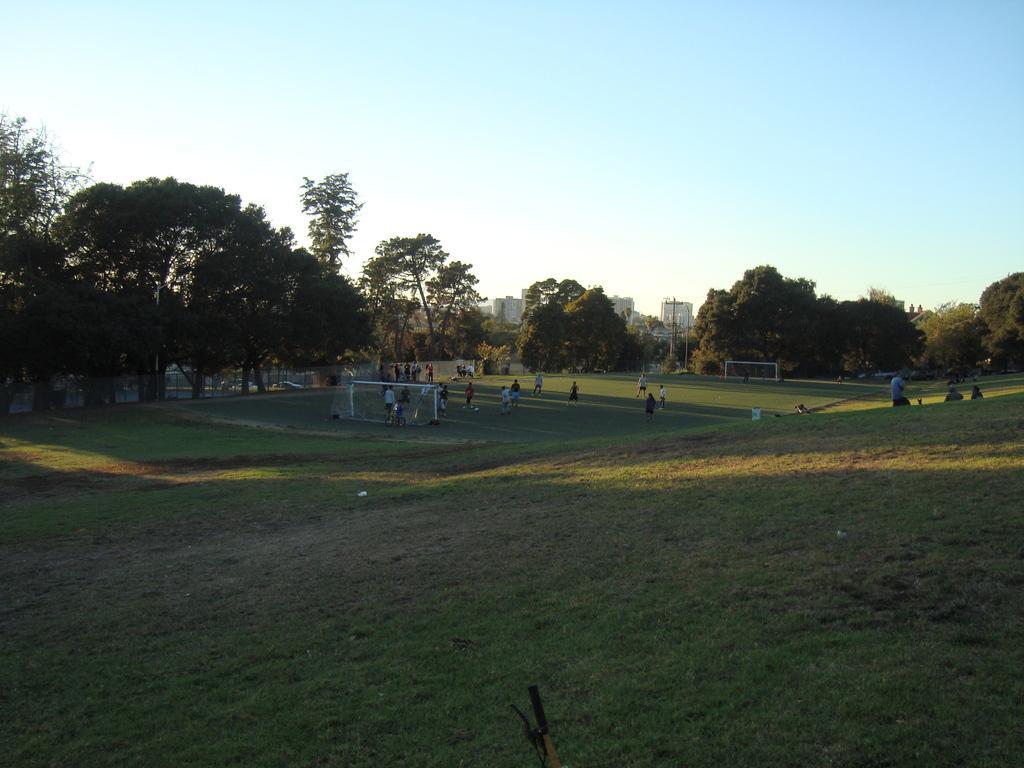Can you describe this image briefly? These are the trees with branches and leaves. This looks like a football goal. I can see groups of people standing. Here is the grass. In the background, I can see the buildings. This is the sky. At the bottom of the image, that looks like a vehicle handle. 